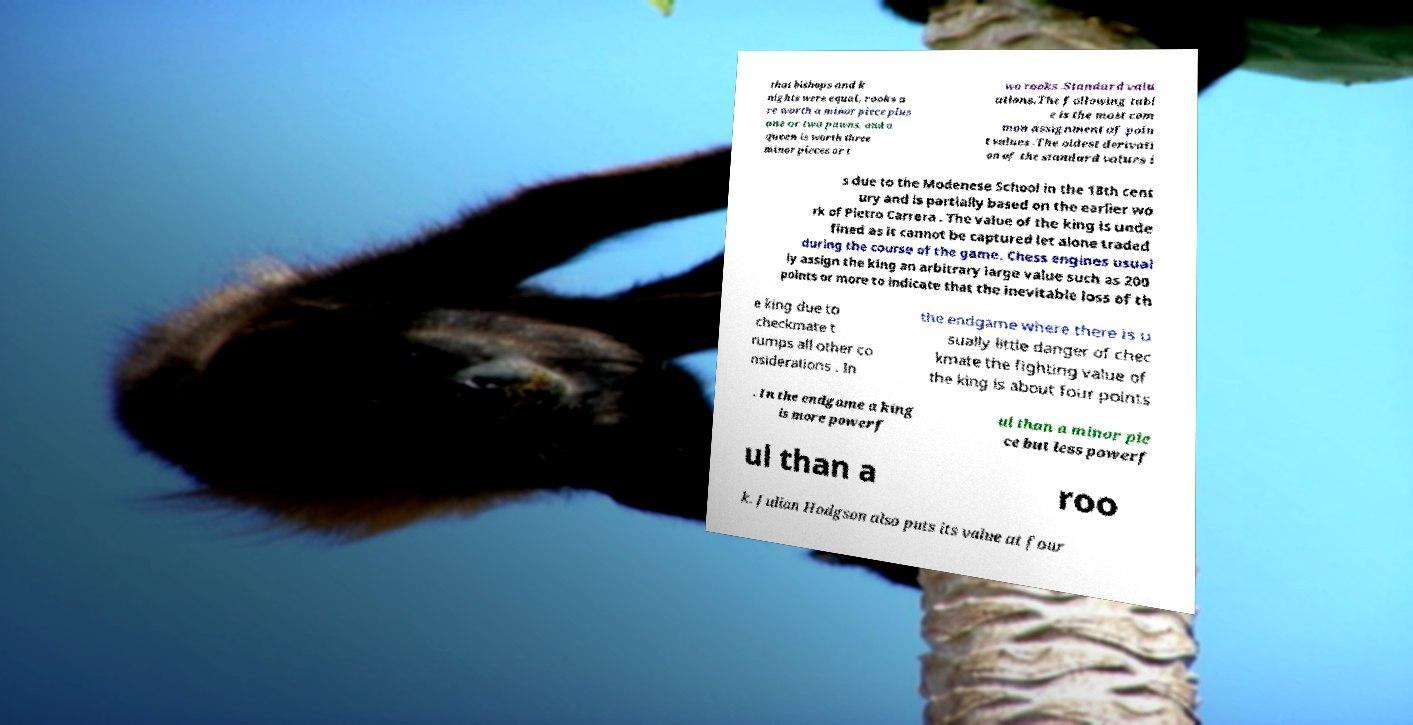For documentation purposes, I need the text within this image transcribed. Could you provide that? that bishops and k nights were equal, rooks a re worth a minor piece plus one or two pawns, and a queen is worth three minor pieces or t wo rooks .Standard valu ations.The following tabl e is the most com mon assignment of poin t values .The oldest derivati on of the standard values i s due to the Modenese School in the 18th cent ury and is partially based on the earlier wo rk of Pietro Carrera . The value of the king is unde fined as it cannot be captured let alone traded during the course of the game. Chess engines usual ly assign the king an arbitrary large value such as 200 points or more to indicate that the inevitable loss of th e king due to checkmate t rumps all other co nsiderations . In the endgame where there is u sually little danger of chec kmate the fighting value of the king is about four points . In the endgame a king is more powerf ul than a minor pie ce but less powerf ul than a roo k. Julian Hodgson also puts its value at four 